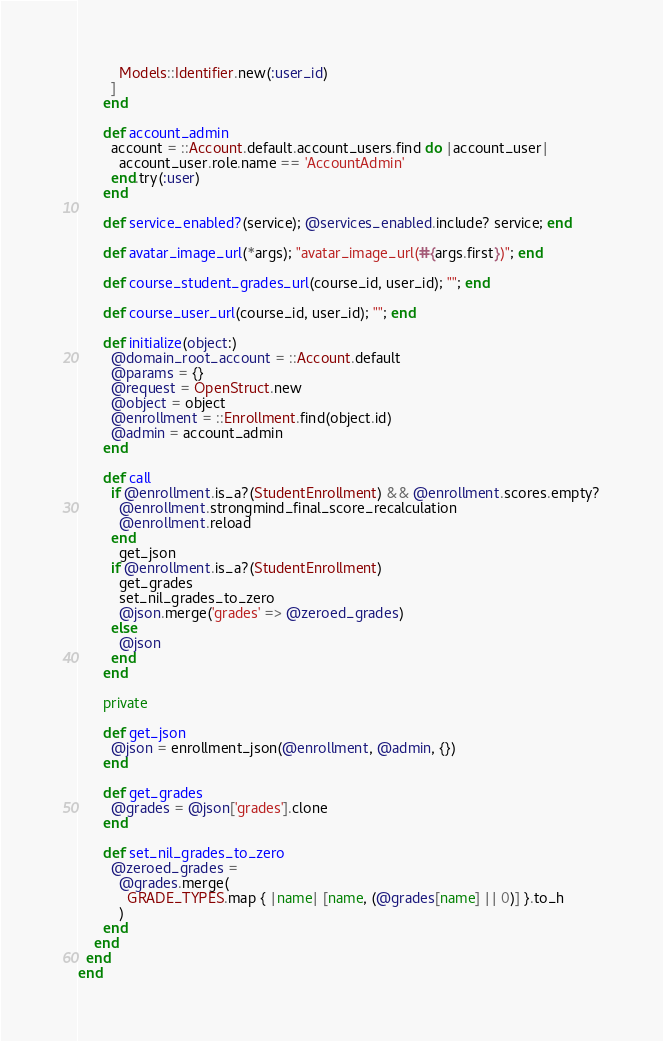Convert code to text. <code><loc_0><loc_0><loc_500><loc_500><_Ruby_>          Models::Identifier.new(:user_id)
        ]
      end

      def account_admin
        account = ::Account.default.account_users.find do |account_user|
          account_user.role.name == 'AccountAdmin'
        end.try(:user)
      end

      def service_enabled?(service); @services_enabled.include? service; end

      def avatar_image_url(*args); "avatar_image_url(#{args.first})"; end

      def course_student_grades_url(course_id, user_id); ""; end

      def course_user_url(course_id, user_id); ""; end

      def initialize(object:)
        @domain_root_account = ::Account.default
        @params = {}
        @request = OpenStruct.new
        @object = object
        @enrollment = ::Enrollment.find(object.id)
        @admin = account_admin
      end

      def call
        if @enrollment.is_a?(StudentEnrollment) && @enrollment.scores.empty?
          @enrollment.strongmind_final_score_recalculation
          @enrollment.reload
        end
          get_json
        if @enrollment.is_a?(StudentEnrollment)
          get_grades
          set_nil_grades_to_zero
          @json.merge('grades' => @zeroed_grades)
        else
          @json
        end
      end
      
      private

      def get_json
        @json = enrollment_json(@enrollment, @admin, {})
      end

      def get_grades
        @grades = @json['grades'].clone
      end

      def set_nil_grades_to_zero
        @zeroed_grades = 
          @grades.merge(
            GRADE_TYPES.map { |name| [name, (@grades[name] || 0)] }.to_h
          )
      end
    end
  end
end
</code> 